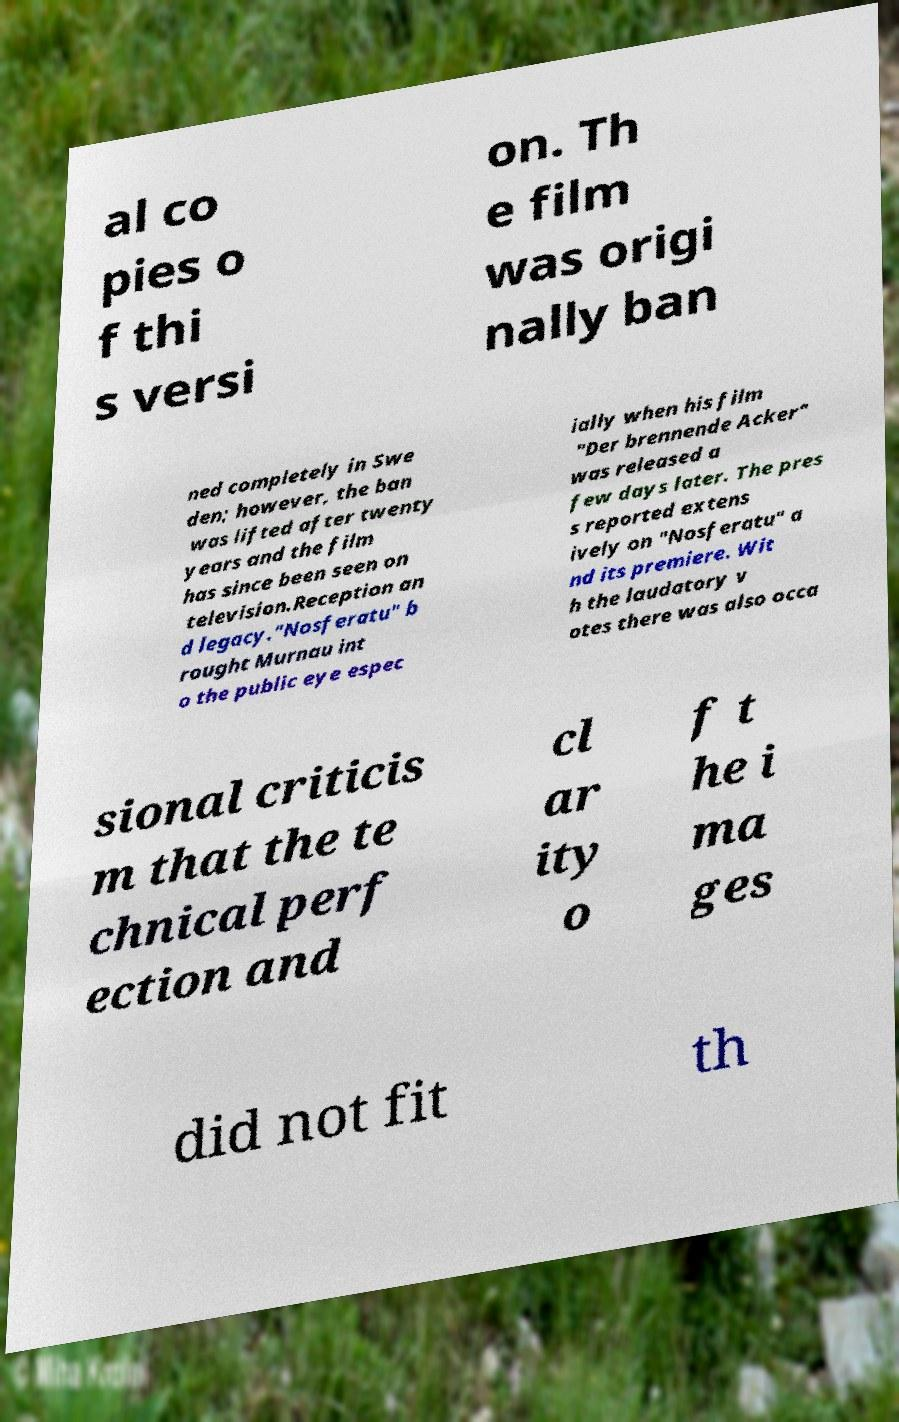There's text embedded in this image that I need extracted. Can you transcribe it verbatim? al co pies o f thi s versi on. Th e film was origi nally ban ned completely in Swe den; however, the ban was lifted after twenty years and the film has since been seen on television.Reception an d legacy."Nosferatu" b rought Murnau int o the public eye espec ially when his film "Der brennende Acker" was released a few days later. The pres s reported extens ively on "Nosferatu" a nd its premiere. Wit h the laudatory v otes there was also occa sional criticis m that the te chnical perf ection and cl ar ity o f t he i ma ges did not fit th 